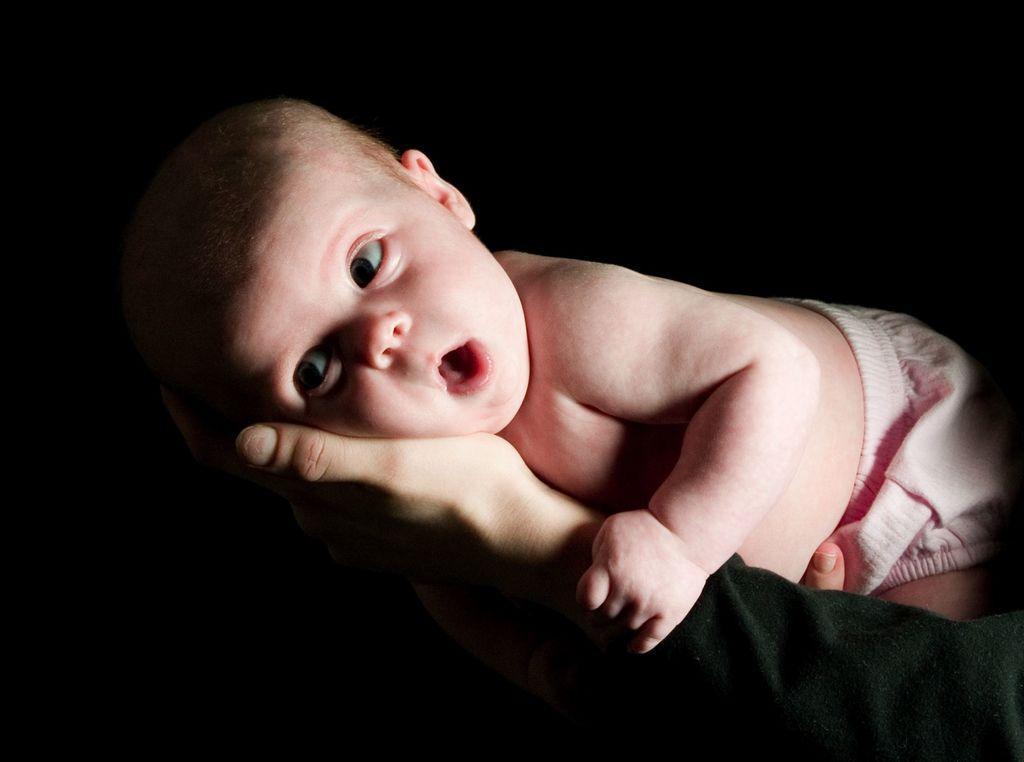How would you summarize this image in a sentence or two? In this image, I can see a baby lying on a person's hands. The background looks dark. 